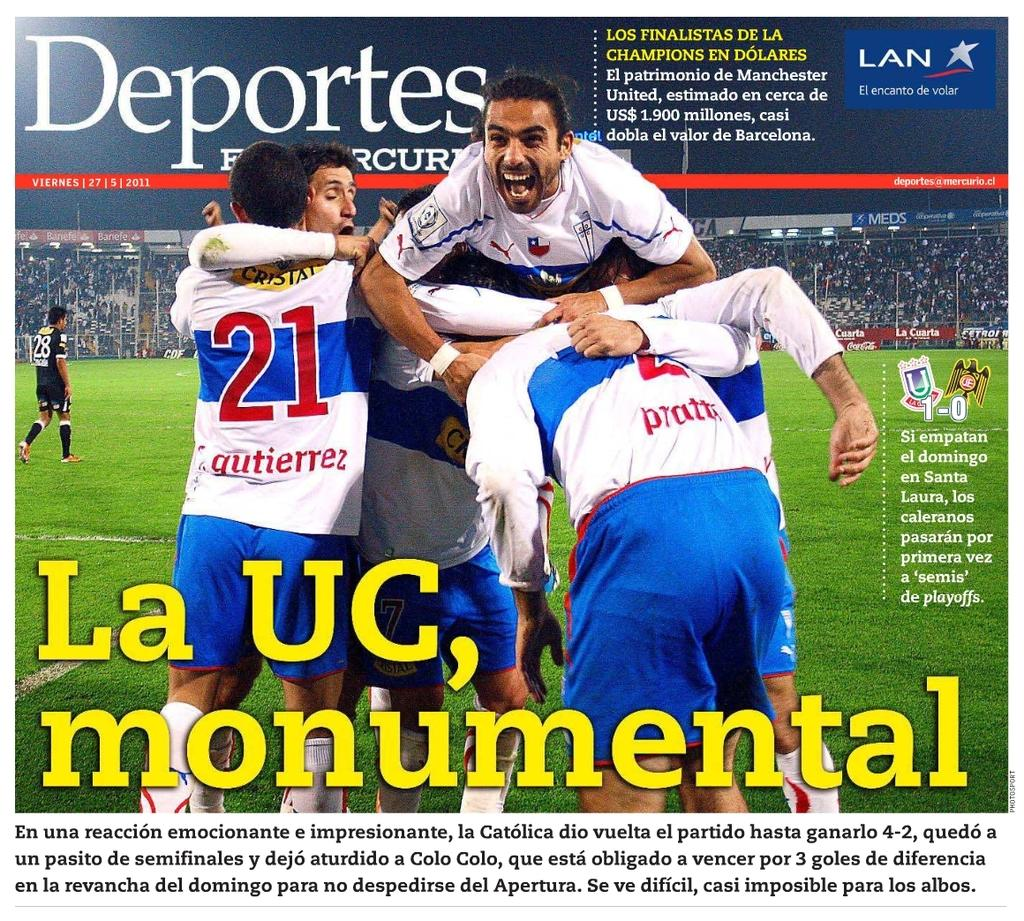<image>
Share a concise interpretation of the image provided. A poster has a title La UC, monumental with a picture of soccer players. 